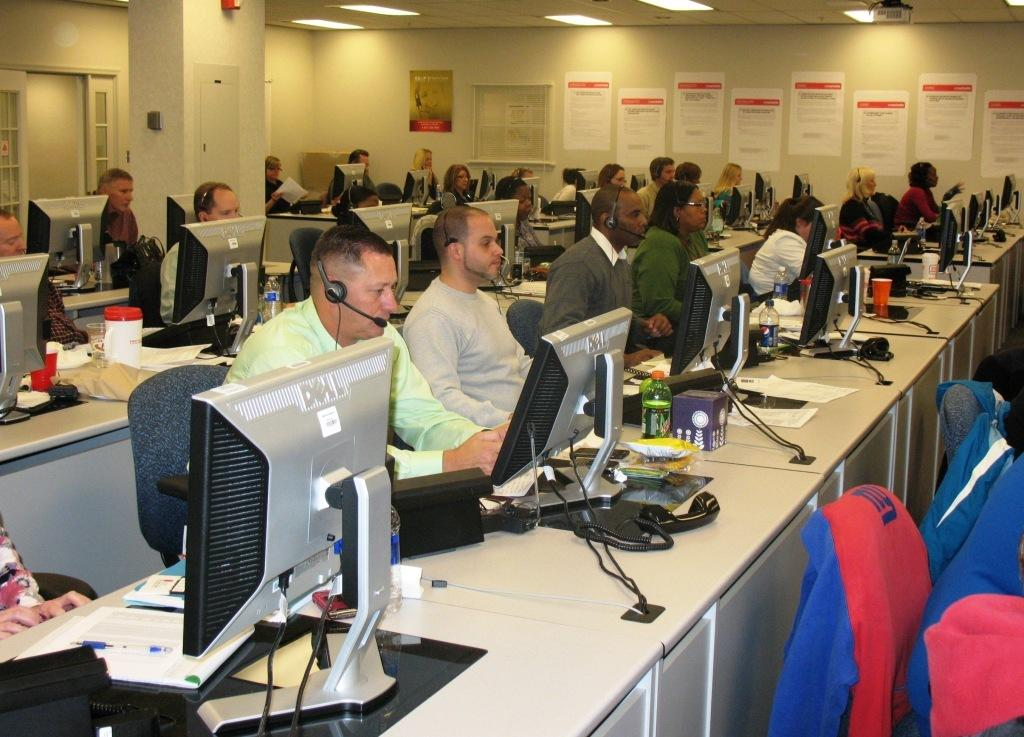<image>
Write a terse but informative summary of the picture. A row of workers working at computer stations, using Dell monitors. 